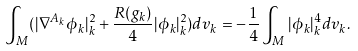Convert formula to latex. <formula><loc_0><loc_0><loc_500><loc_500>\int _ { M } ( | \nabla ^ { A _ { k } } \phi _ { k } | _ { k } ^ { 2 } + \frac { R ( g _ { k } ) } { 4 } | \phi _ { k } | _ { k } ^ { 2 } ) d v _ { k } = - \frac { 1 } { 4 } \int _ { M } | \phi _ { k } | _ { k } ^ { 4 } d v _ { k } .</formula> 